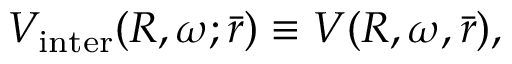<formula> <loc_0><loc_0><loc_500><loc_500>V _ { i n t e r } ( R , \omega ; \bar { r } ) \equiv V ( R , \omega , \bar { r } ) ,</formula> 